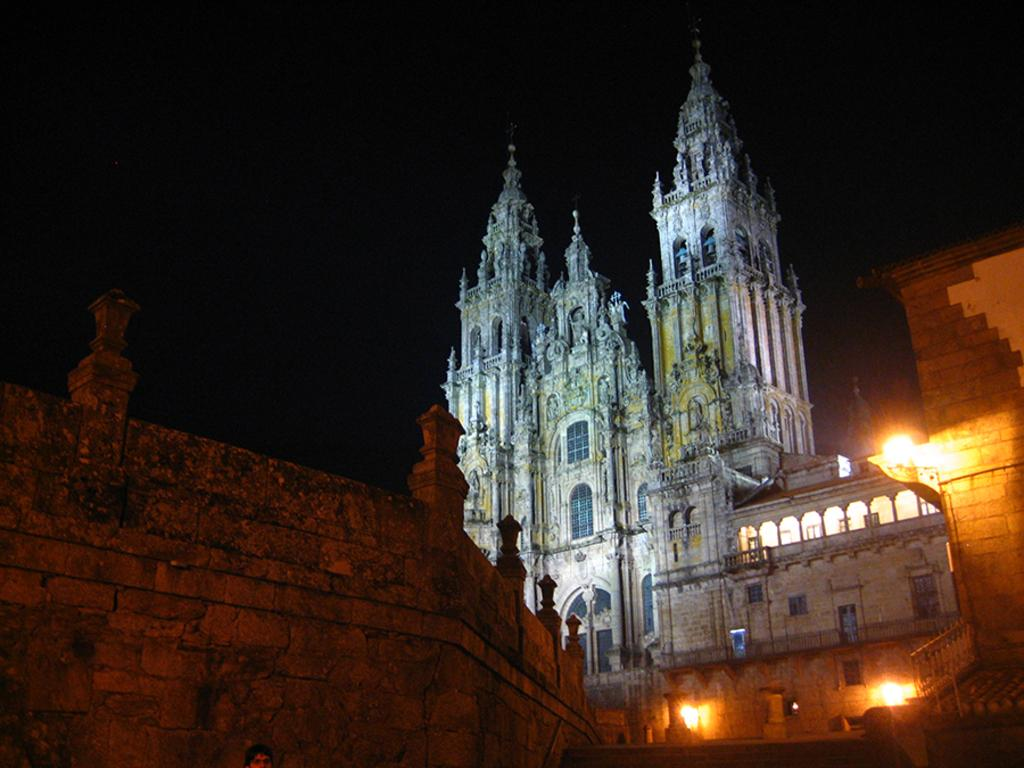What type of structures can be seen in the image? There are buildings in the image. What else is visible in the image besides the buildings? There are lights in the image. What is visible at the top of the image? The sky is visible at the top of the image. Can you tell me the position of the bear in the image? There is no bear present in the image. What color is the goldfish in the image? There is no goldfish present in the image. 